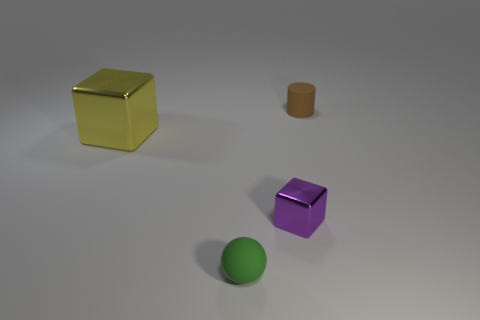Do the tiny ball and the matte object that is behind the small purple block have the same color?
Your answer should be very brief. No. How many other objects are there of the same size as the green sphere?
Keep it short and to the point. 2. The tiny matte object that is in front of the metallic thing that is in front of the cube on the left side of the tiny green thing is what shape?
Offer a terse response. Sphere. There is a brown rubber cylinder; is it the same size as the metallic object that is on the left side of the green ball?
Ensure brevity in your answer.  No. There is a thing that is both behind the tiny cube and to the right of the green ball; what color is it?
Your answer should be very brief. Brown. What number of other objects are there of the same shape as the yellow thing?
Ensure brevity in your answer.  1. There is a tiny rubber thing that is left of the small brown rubber thing; is it the same color as the matte object that is on the right side of the tiny ball?
Your response must be concise. No. There is a matte object that is left of the brown matte thing; is it the same size as the rubber object to the right of the tiny green matte ball?
Ensure brevity in your answer.  Yes. Are there any other things that have the same material as the tiny purple cube?
Your answer should be very brief. Yes. What is the block that is to the right of the tiny rubber thing in front of the small rubber thing that is to the right of the small green rubber thing made of?
Provide a short and direct response. Metal. 